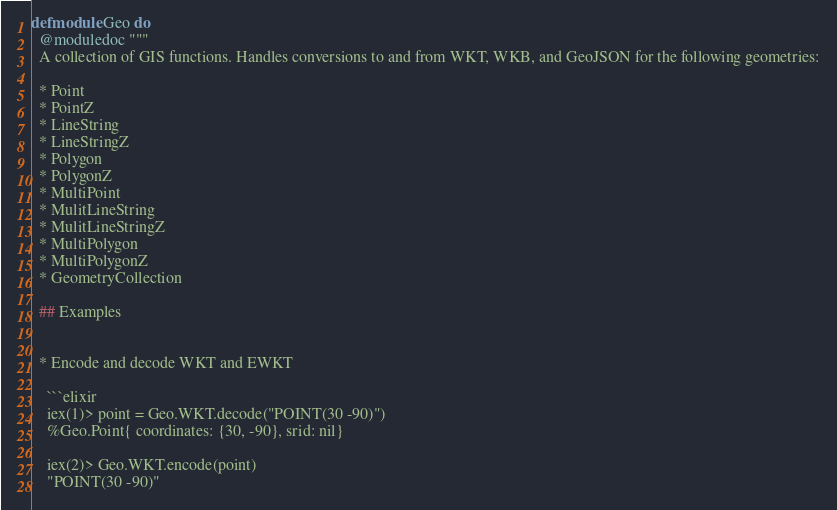Convert code to text. <code><loc_0><loc_0><loc_500><loc_500><_Elixir_>defmodule Geo do
  @moduledoc """
  A collection of GIS functions. Handles conversions to and from WKT, WKB, and GeoJSON for the following geometries:

  * Point
  * PointZ
  * LineString
  * LineStringZ
  * Polygon
  * PolygonZ
  * MultiPoint
  * MulitLineString
  * MulitLineStringZ
  * MultiPolygon
  * MultiPolygonZ
  * GeometryCollection

  ## Examples


  * Encode and decode WKT and EWKT

    ```elixir
    iex(1)> point = Geo.WKT.decode("POINT(30 -90)")
    %Geo.Point{ coordinates: {30, -90}, srid: nil}

    iex(2)> Geo.WKT.encode(point)
    "POINT(30 -90)"
</code> 